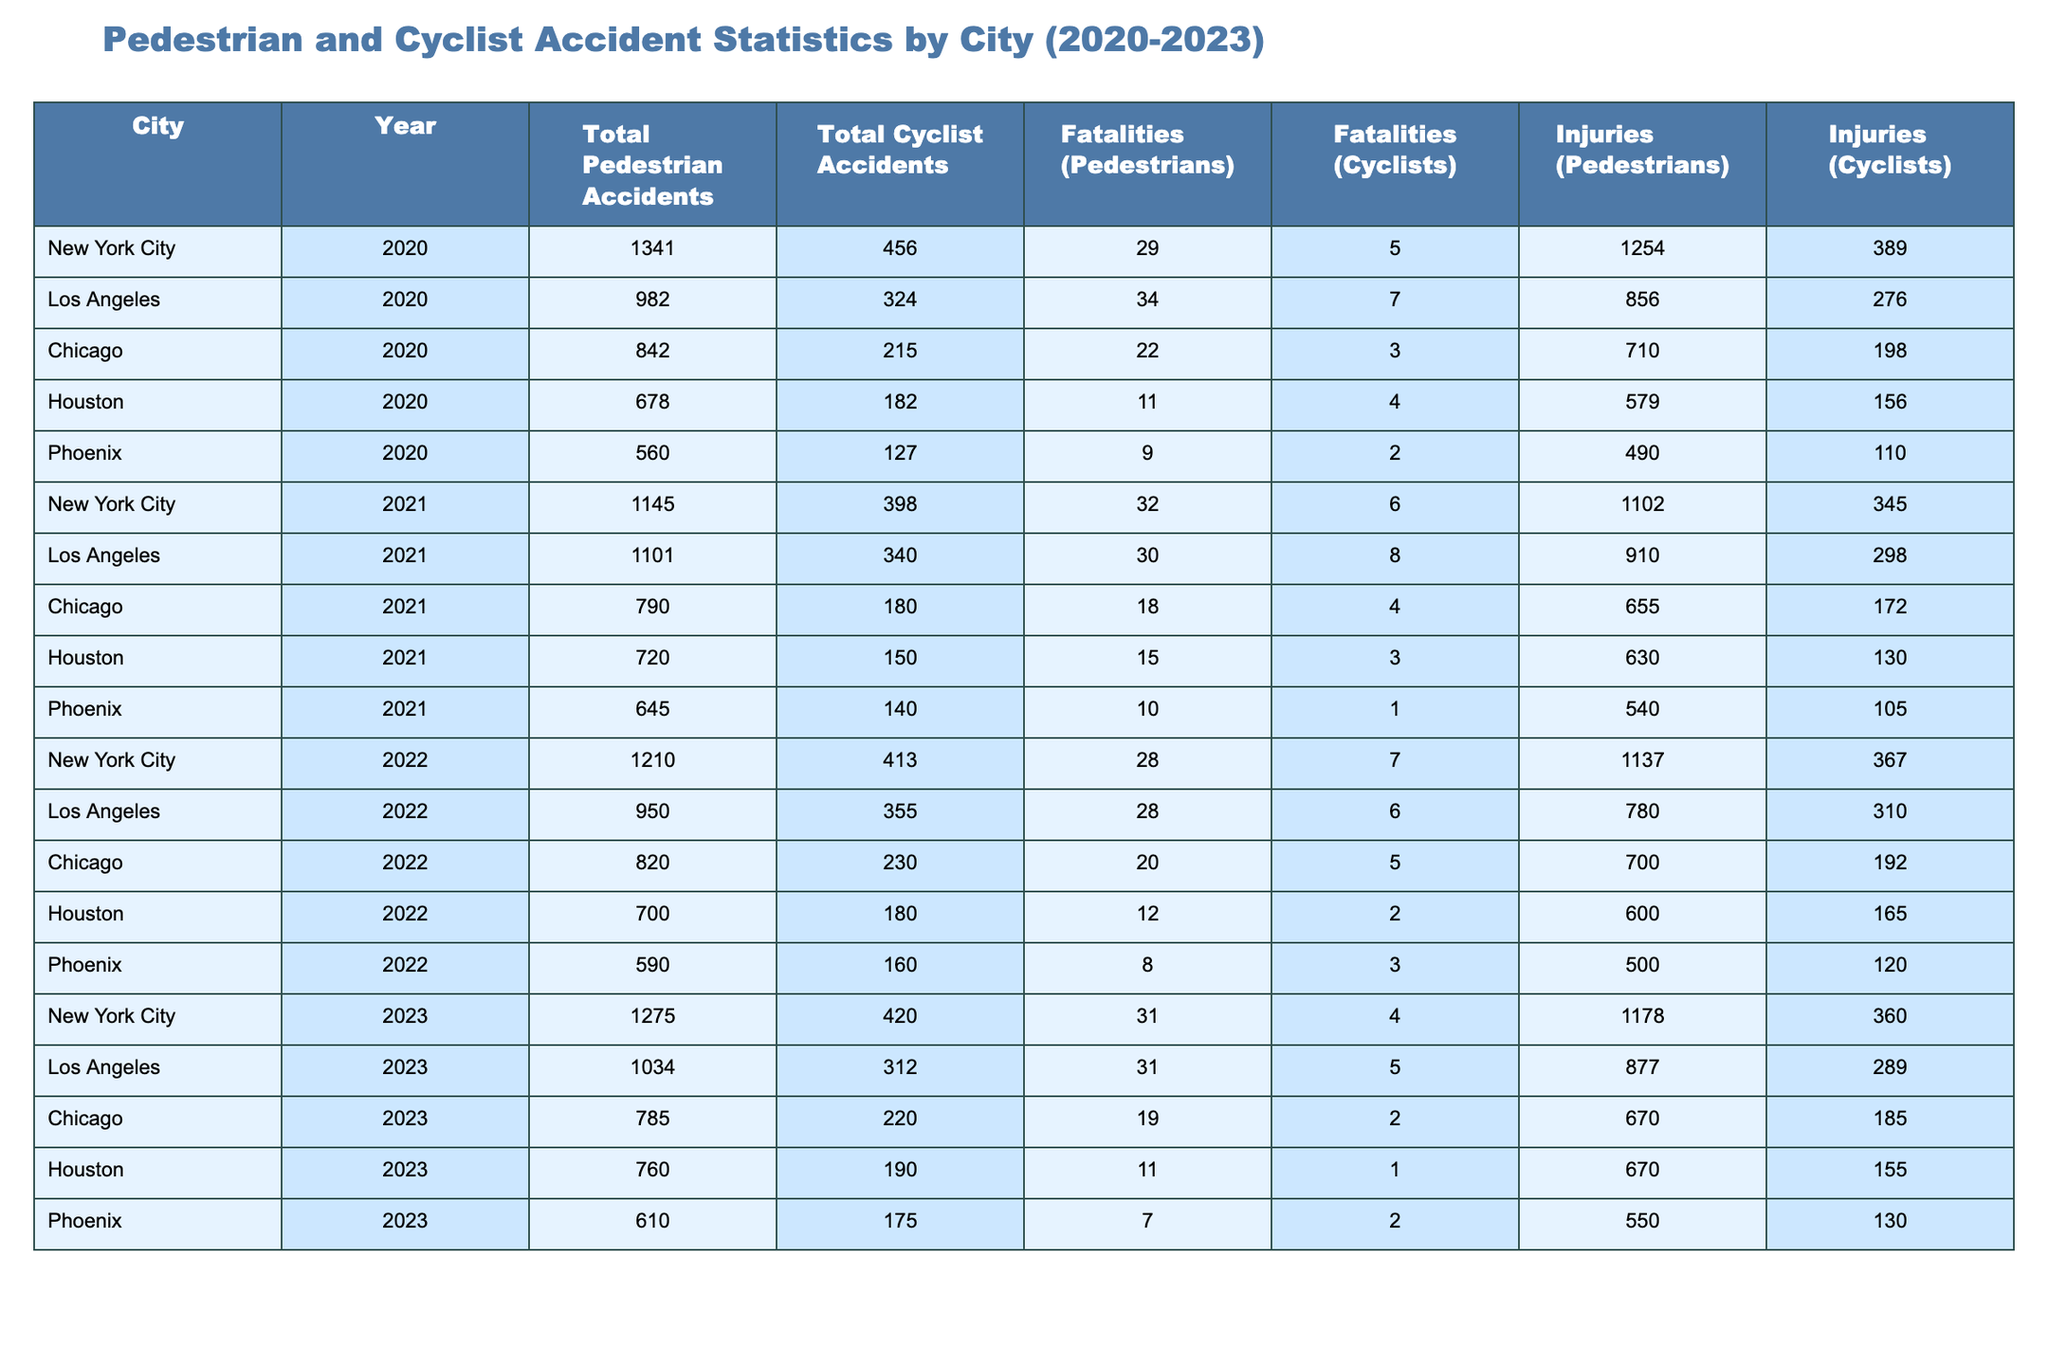What city had the highest total pedestrian accidents in 2020? Referring to the table, New York City has the highest total pedestrian accidents with 1341 in 2020.
Answer: New York City In which year did Chicago have the least number of pedestrian accidents? By examining the data for Chicago, the least number of pedestrian accidents occurred in 2021 with 790 total accidents.
Answer: 2021 True or false: In 2022, Houston had more pedestrian accidents than Phoenix. Checking the table, Houston had 700 pedestrian accidents while Phoenix had 590 in 2022; thus, the statement is true.
Answer: True What is the total number of cyclist accidents in Los Angeles from 2020 to 2023? The total cyclist accidents can be calculated by adding the values from the four years: 324 + 340 + 355 + 312 = 1331.
Answer: 1331 Which year saw the highest fatalities among pedestrians in New York City? Looking at New York City's data, 2021 had the highest fatalities among pedestrians, with 32 fatalities reported.
Answer: 2021 How many more injuries were reported for pedestrians in Los Angeles in 2023 compared to 2020? The number of injuries in Los Angeles for pedestrians in 2023 is 877, and in 2020 it was 856. The difference is 877 - 856 = 21.
Answer: 21 Which city had the lowest total fatalities among cyclists in 2020? By comparing the fatalities for cyclists in each city for 2020, Houston had the lowest with 4 fatalities.
Answer: Houston What was the trend in total pedestrian accidents in New York City from 2020 to 2023? The trend can be observed: 1341 (2020) → 1145 (2021) → 1210 (2022) → 1275 (2023). It shows a decrease from 2020 to 2021, then an increase for the following years.
Answer: Decrease then increase What was the average number of pedestrian injuries over the years for Chicago? To find the average injuries: (710 + 655 + 700 + 670) / 4 = 3,735 / 4 = 933.75, rounding gives approximately 934 injuries.
Answer: 934 In which year did the total number of fatalities among cyclists peak in New York City? Reviewing the data for cyclists in New York City reveals that the peak was in 2021 with 6 fatalities.
Answer: 2021 